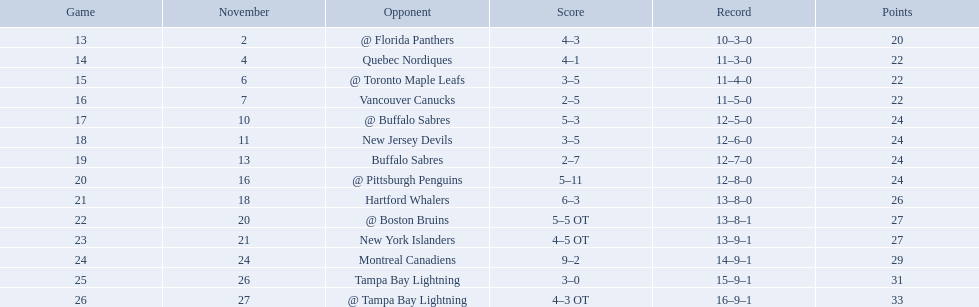Who did the philadelphia flyers play in game 17? @ Buffalo Sabres. What was the score of the november 10th game against the buffalo sabres? 5–3. Which team in the atlantic division had less points than the philadelphia flyers? Tampa Bay Lightning. Parse the table in full. {'header': ['Game', 'November', 'Opponent', 'Score', 'Record', 'Points'], 'rows': [['13', '2', '@ Florida Panthers', '4–3', '10–3–0', '20'], ['14', '4', 'Quebec Nordiques', '4–1', '11–3–0', '22'], ['15', '6', '@ Toronto Maple Leafs', '3–5', '11–4–0', '22'], ['16', '7', 'Vancouver Canucks', '2–5', '11–5–0', '22'], ['17', '10', '@ Buffalo Sabres', '5–3', '12–5–0', '24'], ['18', '11', 'New Jersey Devils', '3–5', '12–6–0', '24'], ['19', '13', 'Buffalo Sabres', '2–7', '12–7–0', '24'], ['20', '16', '@ Pittsburgh Penguins', '5–11', '12–8–0', '24'], ['21', '18', 'Hartford Whalers', '6–3', '13–8–0', '26'], ['22', '20', '@ Boston Bruins', '5–5 OT', '13–8–1', '27'], ['23', '21', 'New York Islanders', '4–5 OT', '13–9–1', '27'], ['24', '24', 'Montreal Canadiens', '9–2', '14–9–1', '29'], ['25', '26', 'Tampa Bay Lightning', '3–0', '15–9–1', '31'], ['26', '27', '@ Tampa Bay Lightning', '4–3 OT', '16–9–1', '33']]} Which teams scored 35 points or more in total? Hartford Whalers, @ Boston Bruins, New York Islanders, Montreal Canadiens, Tampa Bay Lightning, @ Tampa Bay Lightning. Of those teams, which team was the only one to score 3-0? Tampa Bay Lightning. Who are all of the teams? @ Florida Panthers, Quebec Nordiques, @ Toronto Maple Leafs, Vancouver Canucks, @ Buffalo Sabres, New Jersey Devils, Buffalo Sabres, @ Pittsburgh Penguins, Hartford Whalers, @ Boston Bruins, New York Islanders, Montreal Canadiens, Tampa Bay Lightning. What games finished in overtime? 22, 23, 26. In game number 23, who did they face? New York Islanders. What were the scores of the 1993-94 philadelphia flyers season? 4–3, 4–1, 3–5, 2–5, 5–3, 3–5, 2–7, 5–11, 6–3, 5–5 OT, 4–5 OT, 9–2, 3–0, 4–3 OT. Which of these teams had the score 4-5 ot? New York Islanders. What are the team lineups in the atlantic division? Quebec Nordiques, Vancouver Canucks, New Jersey Devils, Buffalo Sabres, Hartford Whalers, New York Islanders, Montreal Canadiens, Tampa Bay Lightning. Which of those registered fewer points than the philadelphia flyers? Tampa Bay Lightning. What were the results of the 1993-94 philadelphia flyers season? 4–3, 4–1, 3–5, 2–5, 5–3, 3–5, 2–7, 5–11, 6–3, 5–5 OT, 4–5 OT, 9–2, 3–0, 4–3 OT. Which of these teams had a 4-5 overtime outcome? New York Islanders. Which squads accumulated a total of 35 points or above? Hartford Whalers, @ Boston Bruins, New York Islanders, Montreal Canadiens, Tampa Bay Lightning, @ Tampa Bay Lightning. From those squads, which was the only one to reach a 3-0 score? Tampa Bay Lightning. Give me the full table as a dictionary. {'header': ['Game', 'November', 'Opponent', 'Score', 'Record', 'Points'], 'rows': [['13', '2', '@ Florida Panthers', '4–3', '10–3–0', '20'], ['14', '4', 'Quebec Nordiques', '4–1', '11–3–0', '22'], ['15', '6', '@ Toronto Maple Leafs', '3–5', '11–4–0', '22'], ['16', '7', 'Vancouver Canucks', '2–5', '11–5–0', '22'], ['17', '10', '@ Buffalo Sabres', '5–3', '12–5–0', '24'], ['18', '11', 'New Jersey Devils', '3–5', '12–6–0', '24'], ['19', '13', 'Buffalo Sabres', '2–7', '12–7–0', '24'], ['20', '16', '@ Pittsburgh Penguins', '5–11', '12–8–0', '24'], ['21', '18', 'Hartford Whalers', '6–3', '13–8–0', '26'], ['22', '20', '@ Boston Bruins', '5–5 OT', '13–8–1', '27'], ['23', '21', 'New York Islanders', '4–5 OT', '13–9–1', '27'], ['24', '24', 'Montreal Canadiens', '9–2', '14–9–1', '29'], ['25', '26', 'Tampa Bay Lightning', '3–0', '15–9–1', '31'], ['26', '27', '@ Tampa Bay Lightning', '4–3 OT', '16–9–1', '33']]} Which groups amassed 35 points or higher in total? Hartford Whalers, @ Boston Bruins, New York Islanders, Montreal Canadiens, Tampa Bay Lightning, @ Tampa Bay Lightning. Among them, which group was the sole one to achieve a 3-0 score? Tampa Bay Lightning. Which team faced the philadelphia flyers in their 17th match? @ Buffalo Sabres. What was the result of the game on the 10th of november versus the buffalo sabres? 5–3. In the atlantic division, which team had fewer points than the philadelphia flyers? Tampa Bay Lightning. In game 17, who were the opponents of the philadelphia flyers? @ Buffalo Sabres. What was the score for the game held on november 10th with the buffalo sabres? 5–3. Which team from the atlantic division had a lower point total than the philadelphia flyers? Tampa Bay Lightning. Which teams had a total score of 35 points or more? Hartford Whalers, @ Boston Bruins, New York Islanders, Montreal Canadiens, Tampa Bay Lightning, @ Tampa Bay Lightning. Among them, which team managed to achieve a 3-0 score? Tampa Bay Lightning. Which teams are included? @ Florida Panthers, Quebec Nordiques, @ Toronto Maple Leafs, Vancouver Canucks, @ Buffalo Sabres, New Jersey Devils, Buffalo Sabres, @ Pittsburgh Penguins, Hartford Whalers, @ Boston Bruins, New York Islanders, Montreal Canadiens, Tampa Bay Lightning. Which matches ended in overtime? 22, 23, 26. In the 23rd game, who was the opposing team? New York Islanders. What were the results? @ Florida Panthers, 4–3, Quebec Nordiques, 4–1, @ Toronto Maple Leafs, 3–5, Vancouver Canucks, 2–5, @ Buffalo Sabres, 5–3, New Jersey Devils, 3–5, Buffalo Sabres, 2–7, @ Pittsburgh Penguins, 5–11, Hartford Whalers, 6–3, @ Boston Bruins, 5–5 OT, New York Islanders, 4–5 OT, Montreal Canadiens, 9–2, Tampa Bay Lightning, 3–0, @ Tampa Bay Lightning, 4–3 OT. Which score was the tightest? New York Islanders, 4–5 OT. What team possessed that score? New York Islanders. 